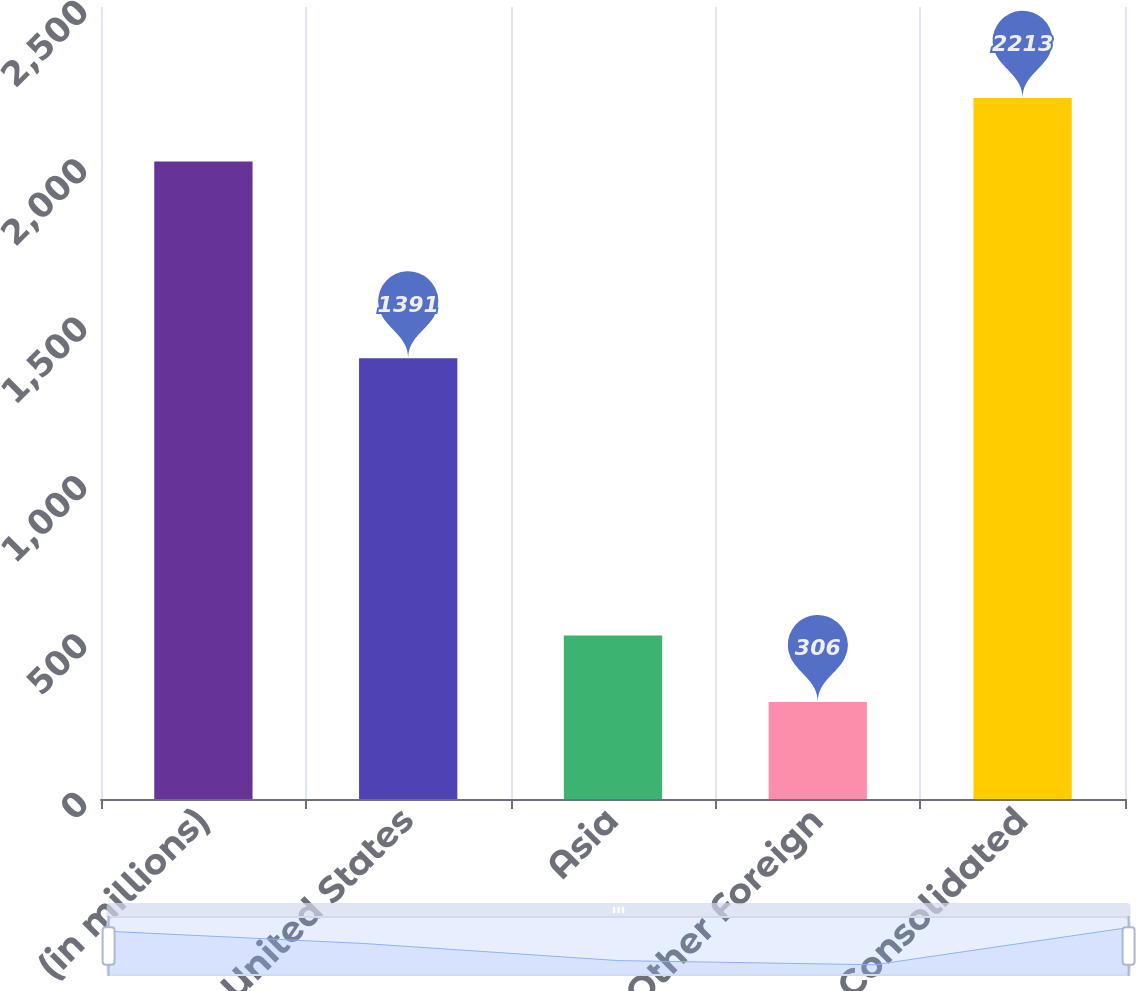<chart> <loc_0><loc_0><loc_500><loc_500><bar_chart><fcel>(in millions)<fcel>United States<fcel>Asia<fcel>Other Foreign<fcel>Consolidated<nl><fcel>2012<fcel>1391<fcel>516<fcel>306<fcel>2213<nl></chart> 